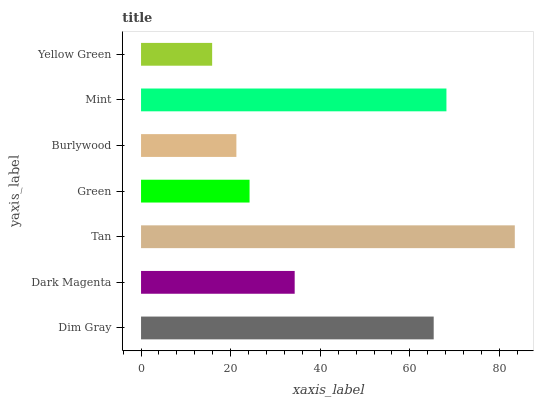Is Yellow Green the minimum?
Answer yes or no. Yes. Is Tan the maximum?
Answer yes or no. Yes. Is Dark Magenta the minimum?
Answer yes or no. No. Is Dark Magenta the maximum?
Answer yes or no. No. Is Dim Gray greater than Dark Magenta?
Answer yes or no. Yes. Is Dark Magenta less than Dim Gray?
Answer yes or no. Yes. Is Dark Magenta greater than Dim Gray?
Answer yes or no. No. Is Dim Gray less than Dark Magenta?
Answer yes or no. No. Is Dark Magenta the high median?
Answer yes or no. Yes. Is Dark Magenta the low median?
Answer yes or no. Yes. Is Yellow Green the high median?
Answer yes or no. No. Is Mint the low median?
Answer yes or no. No. 